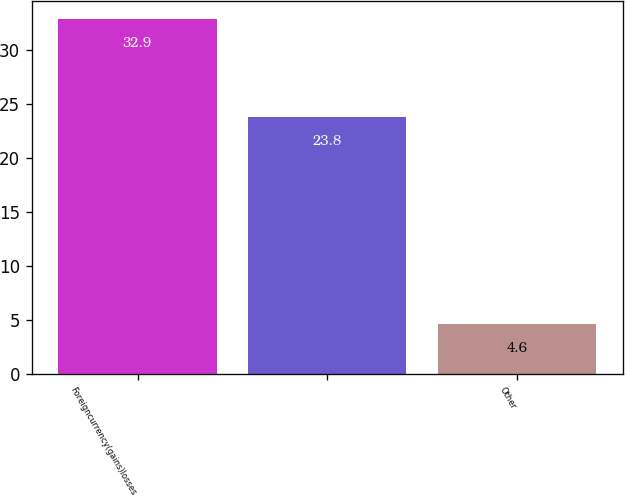Convert chart. <chart><loc_0><loc_0><loc_500><loc_500><bar_chart><fcel>Foreigncurrency(gains)losses<fcel>Unnamed: 1<fcel>Other<nl><fcel>32.9<fcel>23.8<fcel>4.6<nl></chart> 